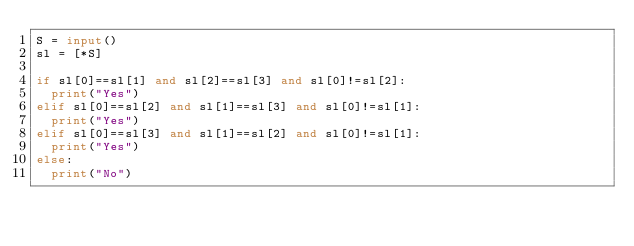<code> <loc_0><loc_0><loc_500><loc_500><_Python_>S = input()
sl = [*S]

if sl[0]==sl[1] and sl[2]==sl[3] and sl[0]!=sl[2]:
  print("Yes")
elif sl[0]==sl[2] and sl[1]==sl[3] and sl[0]!=sl[1]:
  print("Yes")
elif sl[0]==sl[3] and sl[1]==sl[2] and sl[0]!=sl[1]:
  print("Yes")
else:
  print("No")</code> 